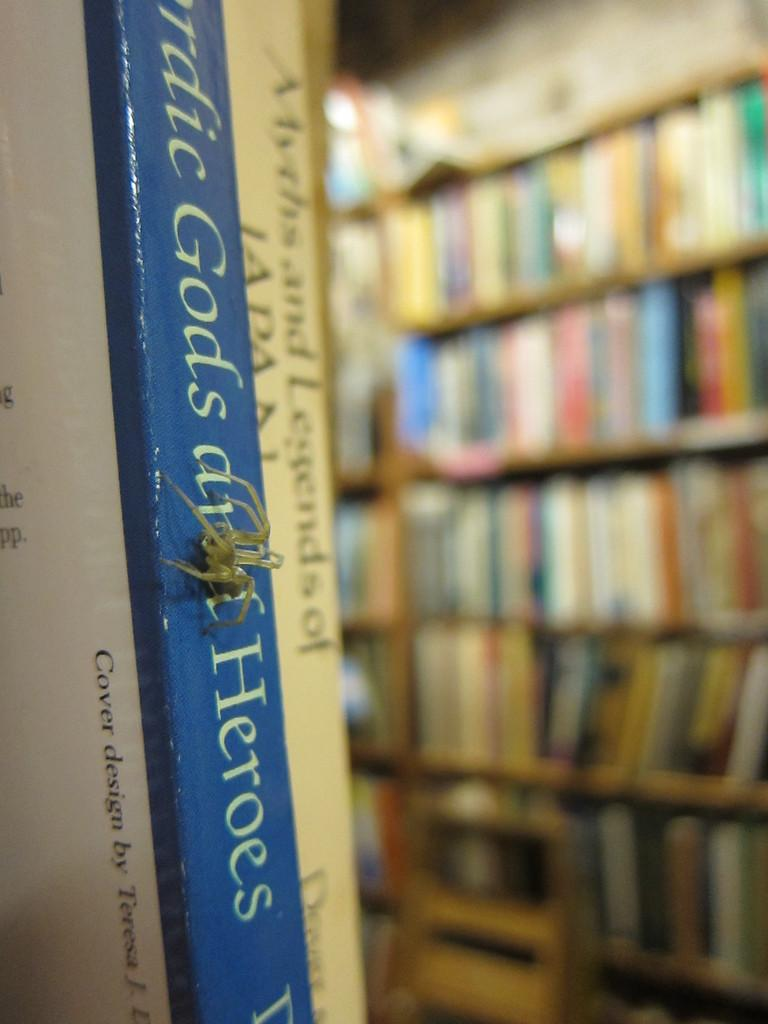<image>
Relay a brief, clear account of the picture shown. A spider crawling along the blue spine of the book titled gods and heroes. 